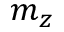<formula> <loc_0><loc_0><loc_500><loc_500>m _ { z }</formula> 